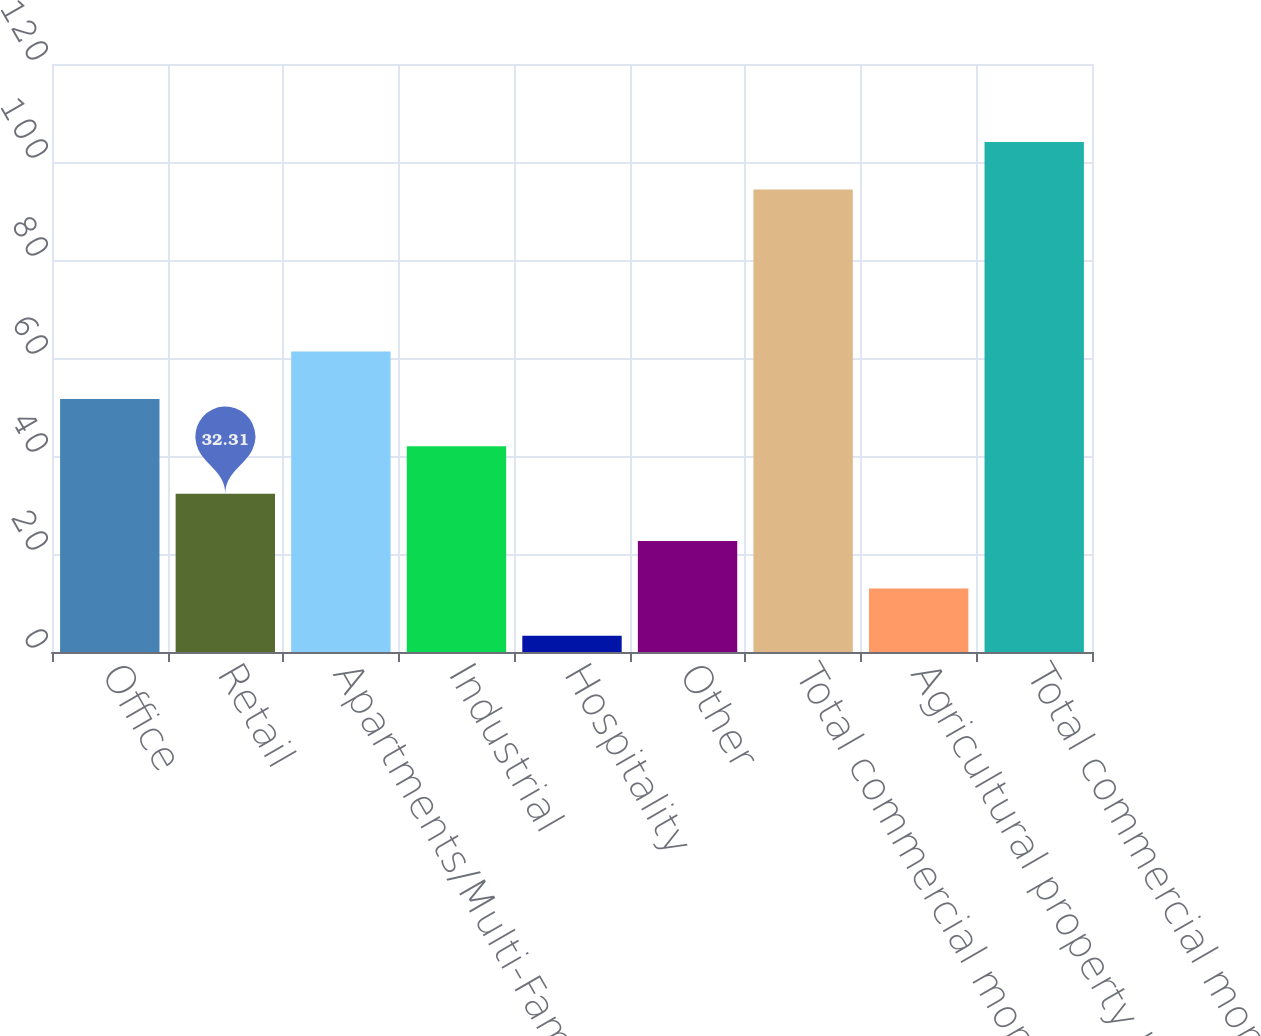<chart> <loc_0><loc_0><loc_500><loc_500><bar_chart><fcel>Office<fcel>Retail<fcel>Apartments/Multi-Family<fcel>Industrial<fcel>Hospitality<fcel>Other<fcel>Total commercial mortgage<fcel>Agricultural property loans<fcel>Total commercial mortgage and<nl><fcel>51.65<fcel>32.31<fcel>61.32<fcel>41.98<fcel>3.3<fcel>22.64<fcel>94.4<fcel>12.97<fcel>104.07<nl></chart> 